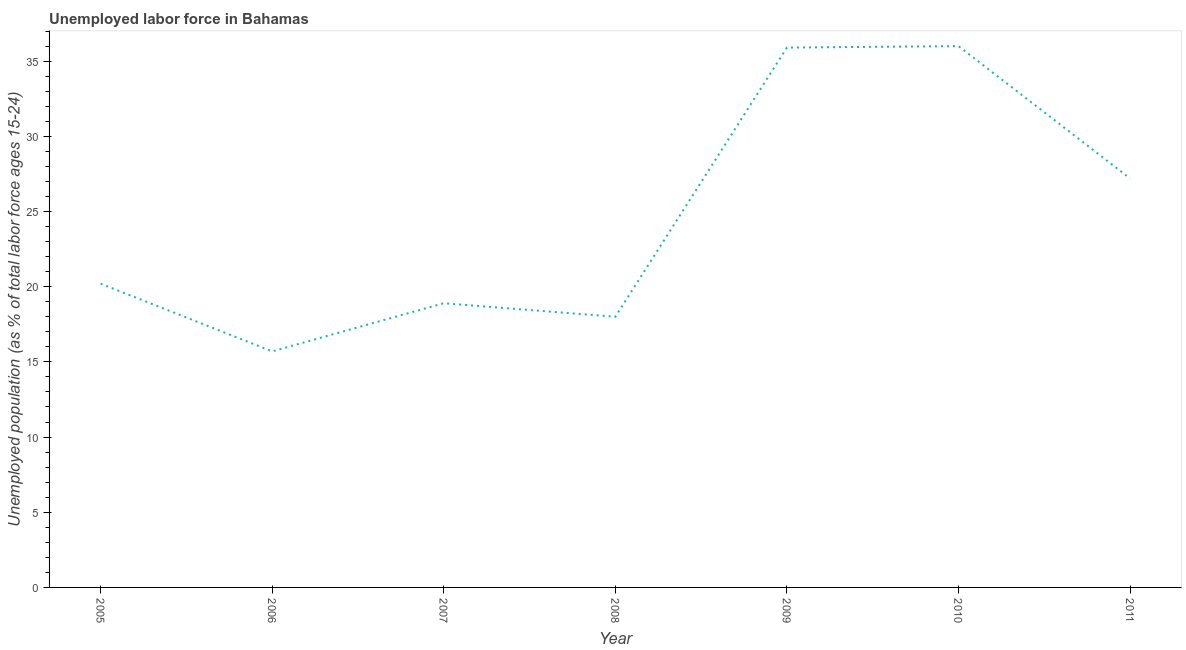What is the total unemployed youth population in 2005?
Your answer should be very brief. 20.2. Across all years, what is the maximum total unemployed youth population?
Provide a short and direct response. 36. Across all years, what is the minimum total unemployed youth population?
Provide a succinct answer. 15.7. What is the sum of the total unemployed youth population?
Your response must be concise. 171.9. What is the difference between the total unemployed youth population in 2006 and 2010?
Keep it short and to the point. -20.3. What is the average total unemployed youth population per year?
Your response must be concise. 24.56. What is the median total unemployed youth population?
Give a very brief answer. 20.2. What is the ratio of the total unemployed youth population in 2007 to that in 2008?
Your response must be concise. 1.05. Is the total unemployed youth population in 2009 less than that in 2011?
Provide a short and direct response. No. Is the difference between the total unemployed youth population in 2005 and 2006 greater than the difference between any two years?
Your answer should be very brief. No. What is the difference between the highest and the second highest total unemployed youth population?
Keep it short and to the point. 0.1. What is the difference between the highest and the lowest total unemployed youth population?
Provide a short and direct response. 20.3. In how many years, is the total unemployed youth population greater than the average total unemployed youth population taken over all years?
Offer a very short reply. 3. How many years are there in the graph?
Keep it short and to the point. 7. What is the title of the graph?
Your answer should be compact. Unemployed labor force in Bahamas. What is the label or title of the X-axis?
Provide a short and direct response. Year. What is the label or title of the Y-axis?
Ensure brevity in your answer.  Unemployed population (as % of total labor force ages 15-24). What is the Unemployed population (as % of total labor force ages 15-24) in 2005?
Provide a short and direct response. 20.2. What is the Unemployed population (as % of total labor force ages 15-24) in 2006?
Your response must be concise. 15.7. What is the Unemployed population (as % of total labor force ages 15-24) of 2007?
Your response must be concise. 18.9. What is the Unemployed population (as % of total labor force ages 15-24) of 2009?
Offer a terse response. 35.9. What is the Unemployed population (as % of total labor force ages 15-24) of 2011?
Your answer should be very brief. 27.2. What is the difference between the Unemployed population (as % of total labor force ages 15-24) in 2005 and 2006?
Provide a succinct answer. 4.5. What is the difference between the Unemployed population (as % of total labor force ages 15-24) in 2005 and 2007?
Provide a succinct answer. 1.3. What is the difference between the Unemployed population (as % of total labor force ages 15-24) in 2005 and 2009?
Give a very brief answer. -15.7. What is the difference between the Unemployed population (as % of total labor force ages 15-24) in 2005 and 2010?
Ensure brevity in your answer.  -15.8. What is the difference between the Unemployed population (as % of total labor force ages 15-24) in 2006 and 2007?
Make the answer very short. -3.2. What is the difference between the Unemployed population (as % of total labor force ages 15-24) in 2006 and 2008?
Your answer should be compact. -2.3. What is the difference between the Unemployed population (as % of total labor force ages 15-24) in 2006 and 2009?
Make the answer very short. -20.2. What is the difference between the Unemployed population (as % of total labor force ages 15-24) in 2006 and 2010?
Make the answer very short. -20.3. What is the difference between the Unemployed population (as % of total labor force ages 15-24) in 2006 and 2011?
Your answer should be very brief. -11.5. What is the difference between the Unemployed population (as % of total labor force ages 15-24) in 2007 and 2009?
Offer a very short reply. -17. What is the difference between the Unemployed population (as % of total labor force ages 15-24) in 2007 and 2010?
Your answer should be very brief. -17.1. What is the difference between the Unemployed population (as % of total labor force ages 15-24) in 2008 and 2009?
Give a very brief answer. -17.9. What is the difference between the Unemployed population (as % of total labor force ages 15-24) in 2008 and 2010?
Keep it short and to the point. -18. What is the difference between the Unemployed population (as % of total labor force ages 15-24) in 2009 and 2010?
Offer a terse response. -0.1. What is the difference between the Unemployed population (as % of total labor force ages 15-24) in 2010 and 2011?
Give a very brief answer. 8.8. What is the ratio of the Unemployed population (as % of total labor force ages 15-24) in 2005 to that in 2006?
Your answer should be compact. 1.29. What is the ratio of the Unemployed population (as % of total labor force ages 15-24) in 2005 to that in 2007?
Your response must be concise. 1.07. What is the ratio of the Unemployed population (as % of total labor force ages 15-24) in 2005 to that in 2008?
Offer a terse response. 1.12. What is the ratio of the Unemployed population (as % of total labor force ages 15-24) in 2005 to that in 2009?
Offer a very short reply. 0.56. What is the ratio of the Unemployed population (as % of total labor force ages 15-24) in 2005 to that in 2010?
Ensure brevity in your answer.  0.56. What is the ratio of the Unemployed population (as % of total labor force ages 15-24) in 2005 to that in 2011?
Ensure brevity in your answer.  0.74. What is the ratio of the Unemployed population (as % of total labor force ages 15-24) in 2006 to that in 2007?
Your answer should be compact. 0.83. What is the ratio of the Unemployed population (as % of total labor force ages 15-24) in 2006 to that in 2008?
Keep it short and to the point. 0.87. What is the ratio of the Unemployed population (as % of total labor force ages 15-24) in 2006 to that in 2009?
Provide a short and direct response. 0.44. What is the ratio of the Unemployed population (as % of total labor force ages 15-24) in 2006 to that in 2010?
Make the answer very short. 0.44. What is the ratio of the Unemployed population (as % of total labor force ages 15-24) in 2006 to that in 2011?
Offer a very short reply. 0.58. What is the ratio of the Unemployed population (as % of total labor force ages 15-24) in 2007 to that in 2008?
Your response must be concise. 1.05. What is the ratio of the Unemployed population (as % of total labor force ages 15-24) in 2007 to that in 2009?
Give a very brief answer. 0.53. What is the ratio of the Unemployed population (as % of total labor force ages 15-24) in 2007 to that in 2010?
Keep it short and to the point. 0.53. What is the ratio of the Unemployed population (as % of total labor force ages 15-24) in 2007 to that in 2011?
Offer a very short reply. 0.69. What is the ratio of the Unemployed population (as % of total labor force ages 15-24) in 2008 to that in 2009?
Your response must be concise. 0.5. What is the ratio of the Unemployed population (as % of total labor force ages 15-24) in 2008 to that in 2011?
Offer a terse response. 0.66. What is the ratio of the Unemployed population (as % of total labor force ages 15-24) in 2009 to that in 2011?
Provide a short and direct response. 1.32. What is the ratio of the Unemployed population (as % of total labor force ages 15-24) in 2010 to that in 2011?
Ensure brevity in your answer.  1.32. 